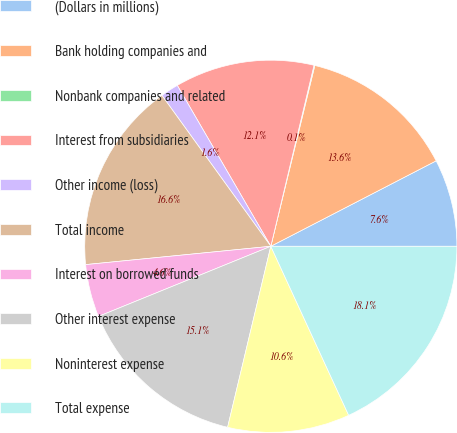<chart> <loc_0><loc_0><loc_500><loc_500><pie_chart><fcel>(Dollars in millions)<fcel>Bank holding companies and<fcel>Nonbank companies and related<fcel>Interest from subsidiaries<fcel>Other income (loss)<fcel>Total income<fcel>Interest on borrowed funds<fcel>Other interest expense<fcel>Noninterest expense<fcel>Total expense<nl><fcel>7.59%<fcel>13.61%<fcel>0.07%<fcel>12.11%<fcel>1.57%<fcel>16.62%<fcel>4.58%<fcel>15.12%<fcel>10.6%<fcel>18.13%<nl></chart> 